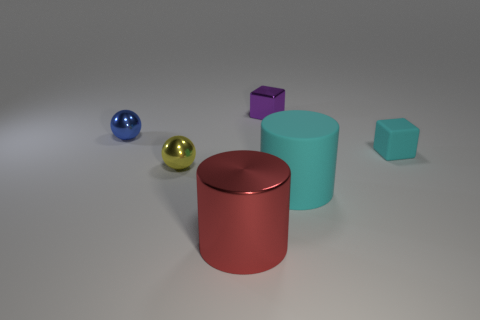There is a object that is the same size as the metallic cylinder; what is it made of?
Ensure brevity in your answer.  Rubber. What material is the small object that is behind the matte cube and on the right side of the large red shiny object?
Keep it short and to the point. Metal. Is there a small yellow object?
Make the answer very short. Yes. Is the color of the rubber cube the same as the big thing to the right of the small purple block?
Ensure brevity in your answer.  Yes. What is the material of the big thing that is the same color as the rubber block?
Ensure brevity in your answer.  Rubber. Are there any other things that have the same shape as the small purple metallic thing?
Provide a succinct answer. Yes. What is the shape of the cyan matte object in front of the tiny cube to the right of the thing behind the tiny blue shiny object?
Your answer should be very brief. Cylinder. What is the shape of the yellow shiny thing?
Your response must be concise. Sphere. What color is the sphere that is to the right of the blue thing?
Your answer should be very brief. Yellow. There is a block that is behind the blue metal sphere; is it the same size as the matte cube?
Make the answer very short. Yes. 